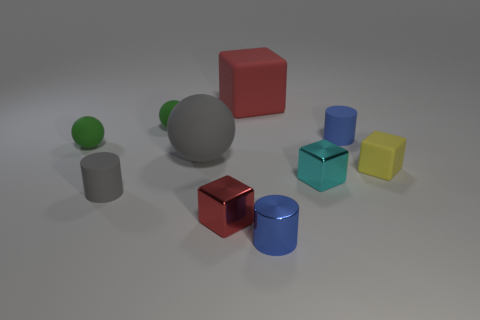What number of small things are yellow blocks or blue blocks?
Provide a short and direct response. 1. There is a red cube behind the metal thing that is on the left side of the big block; are there any small gray rubber cylinders that are right of it?
Give a very brief answer. No. Is there a cyan rubber ball that has the same size as the red metallic thing?
Ensure brevity in your answer.  No. There is a cyan block that is the same size as the red shiny object; what material is it?
Provide a succinct answer. Metal. There is a cyan shiny thing; does it have the same size as the shiny block on the left side of the blue shiny cylinder?
Your answer should be compact. Yes. How many matte things are either tiny red things or gray objects?
Provide a succinct answer. 2. How many large cyan things have the same shape as the small blue rubber object?
Make the answer very short. 0. There is a tiny thing that is the same color as the metal cylinder; what material is it?
Give a very brief answer. Rubber. There is a rubber thing that is in front of the yellow matte thing; does it have the same size as the red metallic object that is to the left of the large red cube?
Provide a short and direct response. Yes. The big rubber object on the left side of the red rubber cube has what shape?
Ensure brevity in your answer.  Sphere. 